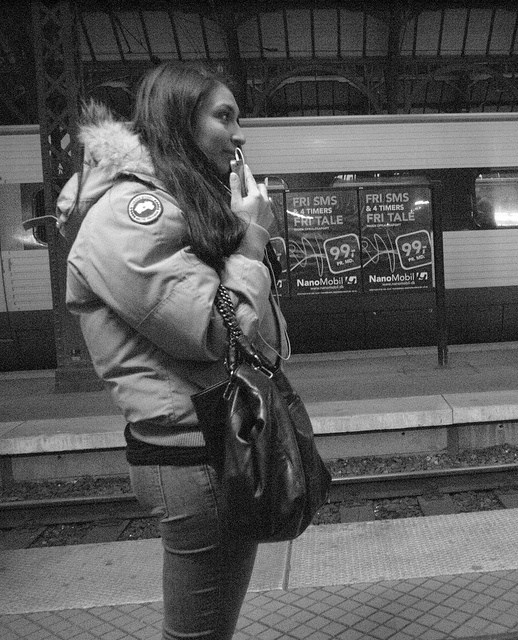Describe the objects in this image and their specific colors. I can see people in black, gray, darkgray, and lightgray tones, train in black, darkgray, gray, and lightgray tones, handbag in black, gray, darkgray, and lightgray tones, and cell phone in black, gray, darkgray, and lightgray tones in this image. 